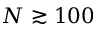<formula> <loc_0><loc_0><loc_500><loc_500>N \gtrsim 1 0 0</formula> 